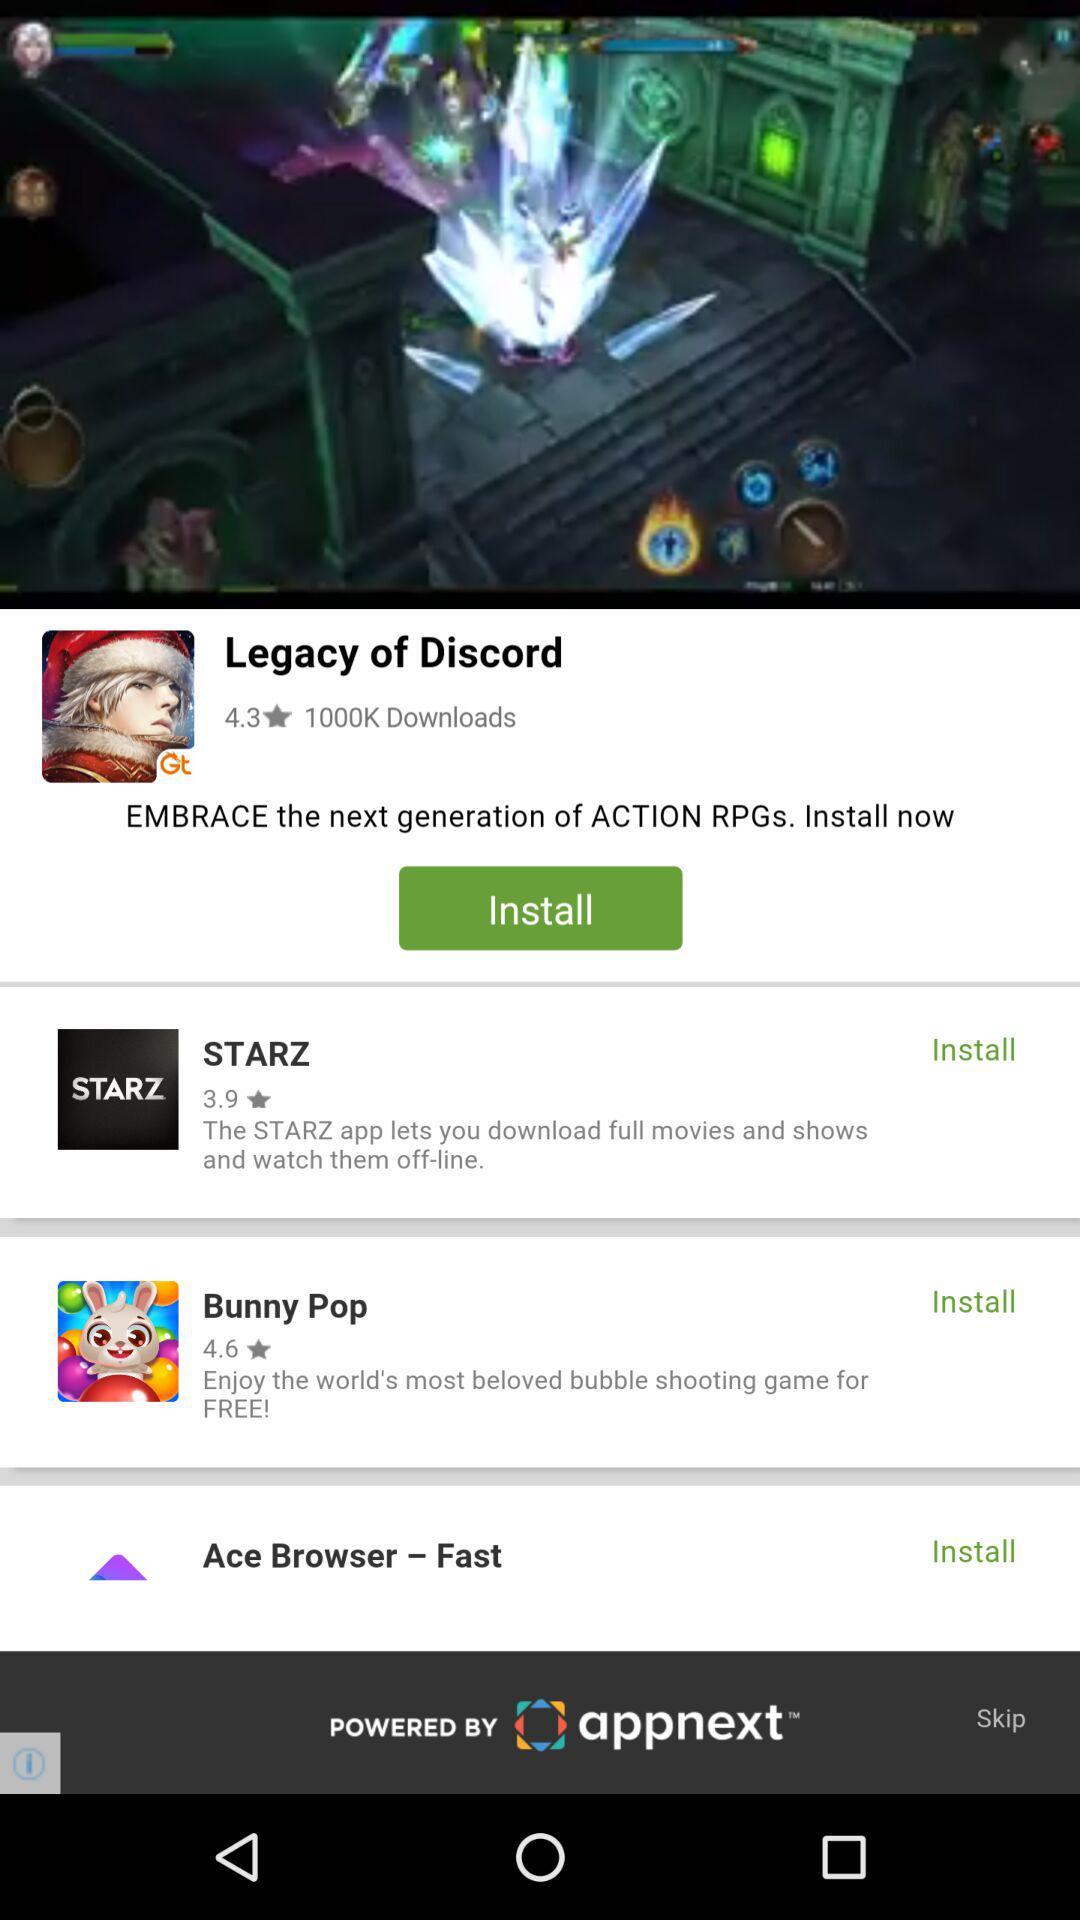What is the star rating of "STARZ"? The star rating is 3.9. 